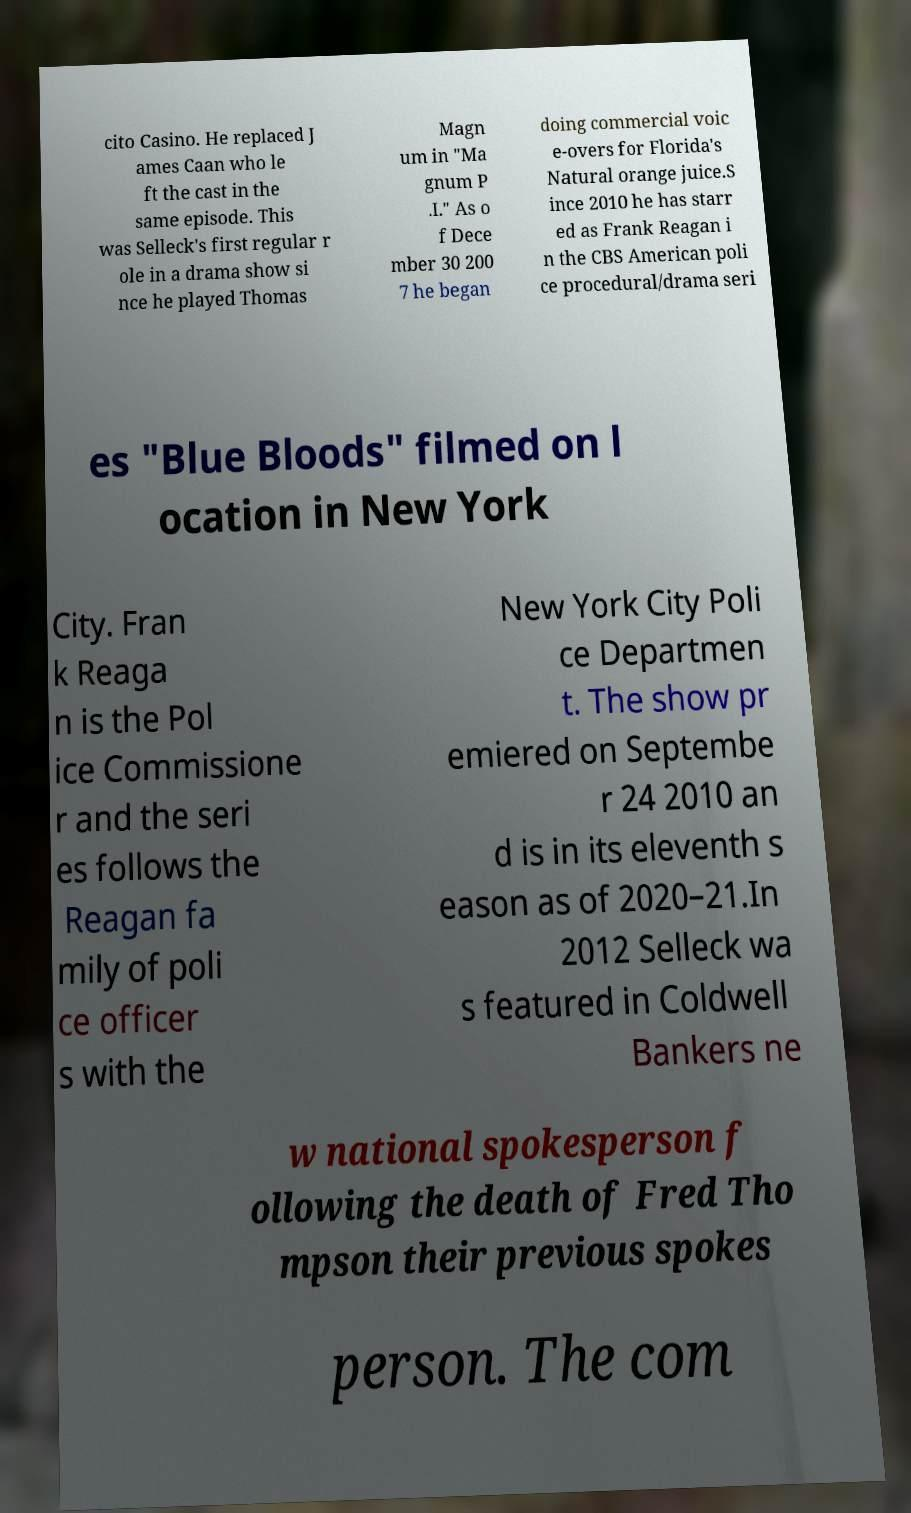I need the written content from this picture converted into text. Can you do that? cito Casino. He replaced J ames Caan who le ft the cast in the same episode. This was Selleck's first regular r ole in a drama show si nce he played Thomas Magn um in "Ma gnum P .I." As o f Dece mber 30 200 7 he began doing commercial voic e-overs for Florida's Natural orange juice.S ince 2010 he has starr ed as Frank Reagan i n the CBS American poli ce procedural/drama seri es "Blue Bloods" filmed on l ocation in New York City. Fran k Reaga n is the Pol ice Commissione r and the seri es follows the Reagan fa mily of poli ce officer s with the New York City Poli ce Departmen t. The show pr emiered on Septembe r 24 2010 an d is in its eleventh s eason as of 2020–21.In 2012 Selleck wa s featured in Coldwell Bankers ne w national spokesperson f ollowing the death of Fred Tho mpson their previous spokes person. The com 